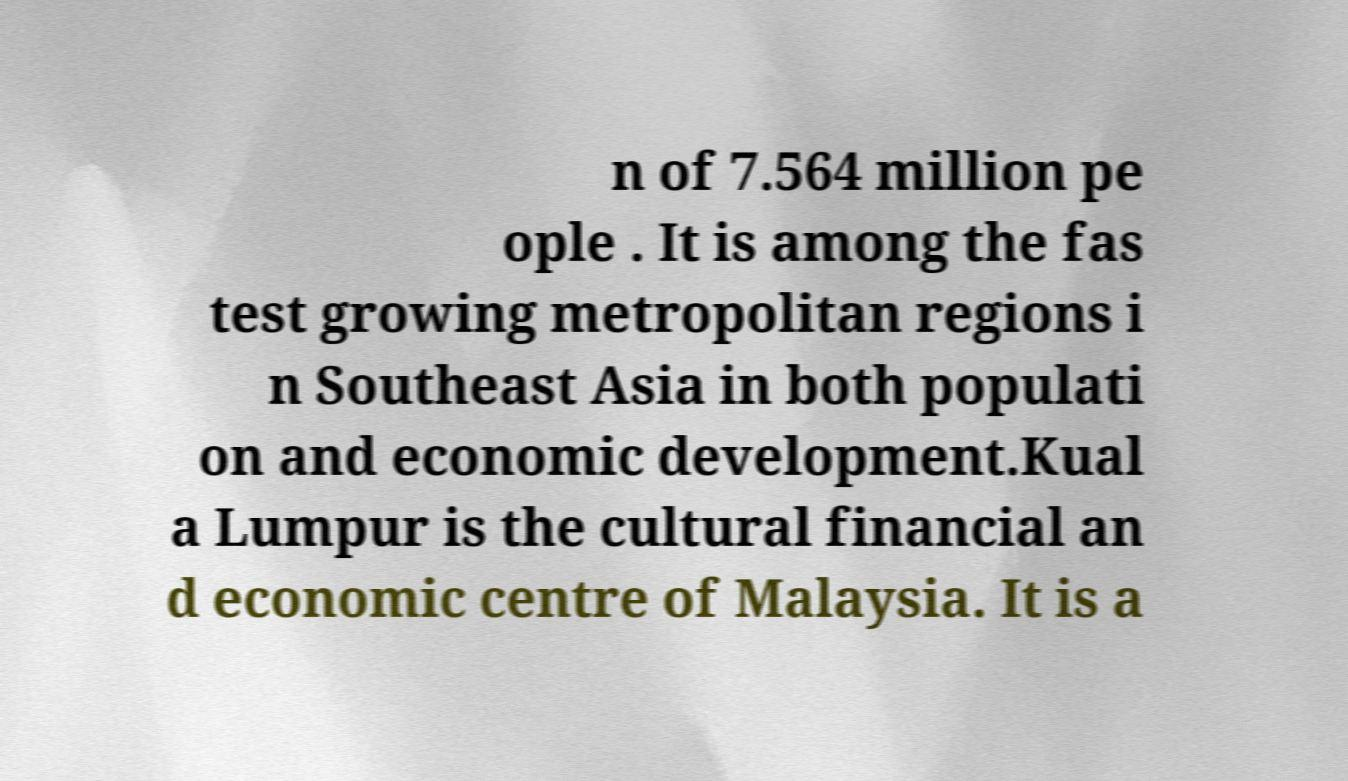What messages or text are displayed in this image? I need them in a readable, typed format. n of 7.564 million pe ople . It is among the fas test growing metropolitan regions i n Southeast Asia in both populati on and economic development.Kual a Lumpur is the cultural financial an d economic centre of Malaysia. It is a 